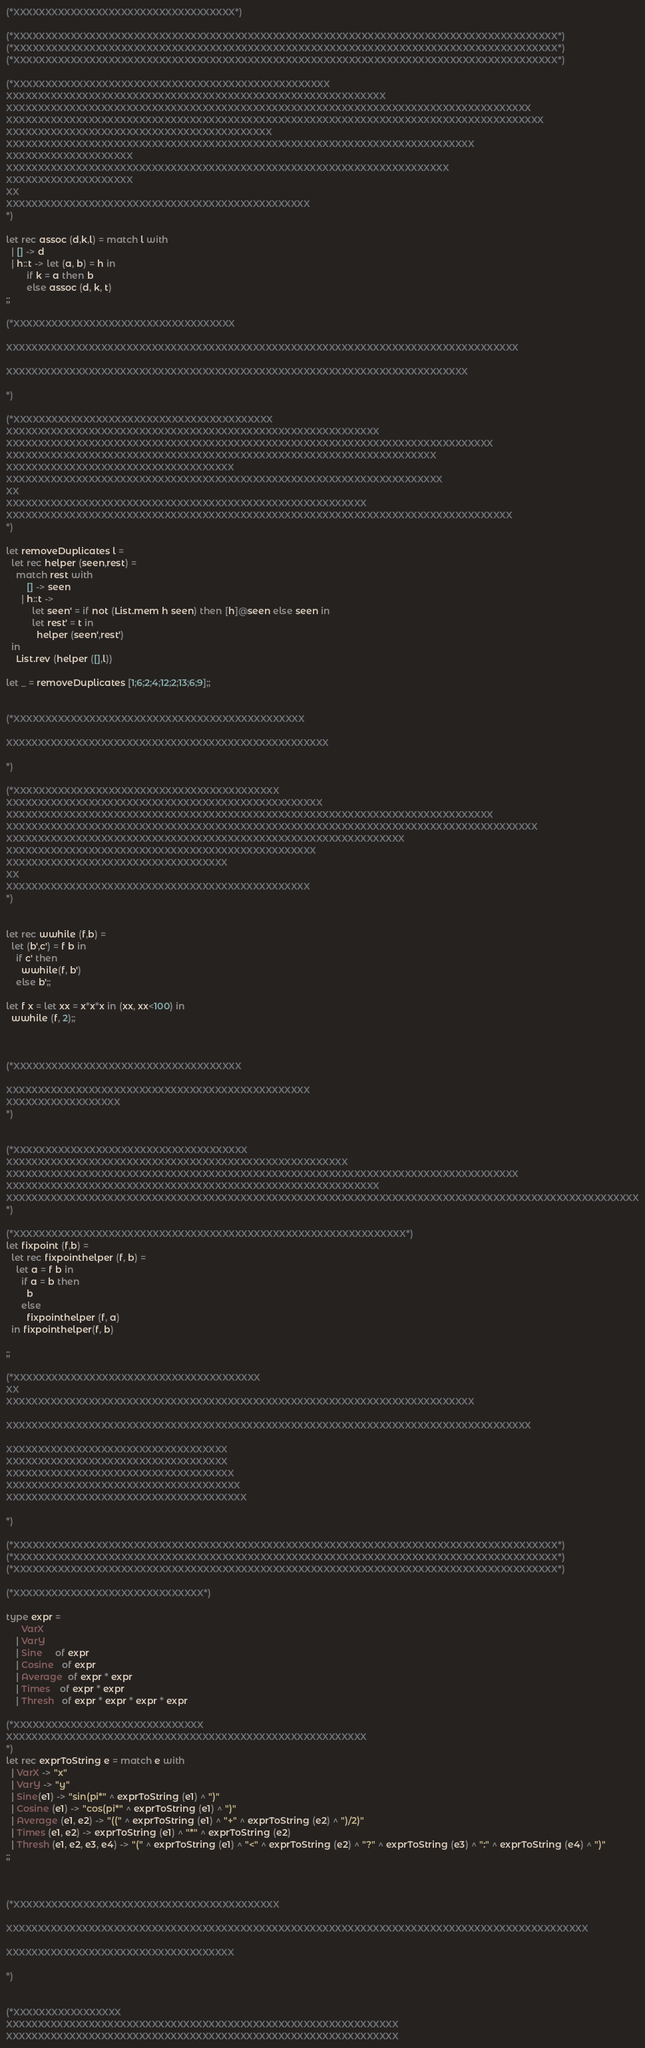Convert code to text. <code><loc_0><loc_0><loc_500><loc_500><_OCaml_>(*XXXXXXXXXXXXXXXXXXXXXXXXXXXXXXXXXXX*)

(*XXXXXXXXXXXXXXXXXXXXXXXXXXXXXXXXXXXXXXXXXXXXXXXXXXXXXXXXXXXXXXXXXXXXXXXXXXXXXXXXXXXXXX*)
(*XXXXXXXXXXXXXXXXXXXXXXXXXXXXXXXXXXXXXXXXXXXXXXXXXXXXXXXXXXXXXXXXXXXXXXXXXXXXXXXXXXXXXX*)
(*XXXXXXXXXXXXXXXXXXXXXXXXXXXXXXXXXXXXXXXXXXXXXXXXXXXXXXXXXXXXXXXXXXXXXXXXXXXXXXXXXXXXXX*)

(*XXXXXXXXXXXXXXXXXXXXXXXXXXXXXXXXXXXXXXXXXXXXXXXXXX
XXXXXXXXXXXXXXXXXXXXXXXXXXXXXXXXXXXXXXXXXXXXXXXXXXXXXXXXXXXX
XXXXXXXXXXXXXXXXXXXXXXXXXXXXXXXXXXXXXXXXXXXXXXXXXXXXXXXXXXXXXXXXXXXXXXXXXXXXXXXXXXX
XXXXXXXXXXXXXXXXXXXXXXXXXXXXXXXXXXXXXXXXXXXXXXXXXXXXXXXXXXXXXXXXXXXXXXXXXXXXXXXXXXXXX
XXXXXXXXXXXXXXXXXXXXXXXXXXXXXXXXXXXXXXXXXX
XXXXXXXXXXXXXXXXXXXXXXXXXXXXXXXXXXXXXXXXXXXXXXXXXXXXXXXXXXXXXXXXXXXXXXXXXX
XXXXXXXXXXXXXXXXXXXX
XXXXXXXXXXXXXXXXXXXXXXXXXXXXXXXXXXXXXXXXXXXXXXXXXXXXXXXXXXXXXXXXXXXXXX
XXXXXXXXXXXXXXXXXXXX
XX
XXXXXXXXXXXXXXXXXXXXXXXXXXXXXXXXXXXXXXXXXXXXXXXX
*)

let rec assoc (d,k,l) = match l with
  | [] -> d
  | h::t -> let (a, b) = h in 
        if k = a then b
        else assoc (d, k, t)
;;

(*XXXXXXXXXXXXXXXXXXXXXXXXXXXXXXXXXXX

XXXXXXXXXXXXXXXXXXXXXXXXXXXXXXXXXXXXXXXXXXXXXXXXXXXXXXXXXXXXXXXXXXXXXXXXXXXXXXXXX

XXXXXXXXXXXXXXXXXXXXXXXXXXXXXXXXXXXXXXXXXXXXXXXXXXXXXXXXXXXXXXXXXXXXXXXXX

*)

(*XXXXXXXXXXXXXXXXXXXXXXXXXXXXXXXXXXXXXXXXX
XXXXXXXXXXXXXXXXXXXXXXXXXXXXXXXXXXXXXXXXXXXXXXXXXXXXXXXXXXX
XXXXXXXXXXXXXXXXXXXXXXXXXXXXXXXXXXXXXXXXXXXXXXXXXXXXXXXXXXXXXXXXXXXXXXXXXXXXX
XXXXXXXXXXXXXXXXXXXXXXXXXXXXXXXXXXXXXXXXXXXXXXXXXXXXXXXXXXXXXXXXXXXX
XXXXXXXXXXXXXXXXXXXXXXXXXXXXXXXXXXXX
XXXXXXXXXXXXXXXXXXXXXXXXXXXXXXXXXXXXXXXXXXXXXXXXXXXXXXXXXXXXXXXXXXXXX
XX
XXXXXXXXXXXXXXXXXXXXXXXXXXXXXXXXXXXXXXXXXXXXXXXXXXXXXXXXX
XXXXXXXXXXXXXXXXXXXXXXXXXXXXXXXXXXXXXXXXXXXXXXXXXXXXXXXXXXXXXXXXXXXXXXXXXXXXXXXX
*)

let removeDuplicates l = 
  let rec helper (seen,rest) = 
    match rest with 
        [] -> seen
      | h::t -> 
          let seen' = if not (List.mem h seen) then [h]@seen else seen in
          let rest' = t in 
            helper (seen',rest') 
  in
    List.rev (helper ([],l))

let _ = removeDuplicates [1;6;2;4;12;2;13;6;9];;


(*XXXXXXXXXXXXXXXXXXXXXXXXXXXXXXXXXXXXXXXXXXXXXX

XXXXXXXXXXXXXXXXXXXXXXXXXXXXXXXXXXXXXXXXXXXXXXXXXXX

*)

(*XXXXXXXXXXXXXXXXXXXXXXXXXXXXXXXXXXXXXXXXXX
XXXXXXXXXXXXXXXXXXXXXXXXXXXXXXXXXXXXXXXXXXXXXXXXXX
XXXXXXXXXXXXXXXXXXXXXXXXXXXXXXXXXXXXXXXXXXXXXXXXXXXXXXXXXXXXXXXXXXXXXXXXXXXXX
XXXXXXXXXXXXXXXXXXXXXXXXXXXXXXXXXXXXXXXXXXXXXXXXXXXXXXXXXXXXXXXXXXXXXXXXXXXXXXXXXXXX
XXXXXXXXXXXXXXXXXXXXXXXXXXXXXXXXXXXXXXXXXXXXXXXXXXXXXXXXXXXXXXX
XXXXXXXXXXXXXXXXXXXXXXXXXXXXXXXXXXXXXXXXXXXXXXXXX
XXXXXXXXXXXXXXXXXXXXXXXXXXXXXXXXXXX
XX
XXXXXXXXXXXXXXXXXXXXXXXXXXXXXXXXXXXXXXXXXXXXXXXX
*)


let rec wwhile (f,b) = 
  let (b',c') = f b in
    if c' then
      wwhile(f, b')
    else b';;

let f x = let xx = x*x*x in (xx, xx<100) in 
  wwhile (f, 2);;



(*XXXXXXXXXXXXXXXXXXXXXXXXXXXXXXXXXXXX

XXXXXXXXXXXXXXXXXXXXXXXXXXXXXXXXXXXXXXXXXXXXXXXX
XXXXXXXXXXXXXXXXXX
*)


(*XXXXXXXXXXXXXXXXXXXXXXXXXXXXXXXXXXXXX
XXXXXXXXXXXXXXXXXXXXXXXXXXXXXXXXXXXXXXXXXXXXXXXXXXXXXX
XXXXXXXXXXXXXXXXXXXXXXXXXXXXXXXXXXXXXXXXXXXXXXXXXXXXXXXXXXXXXXXXXXXXXXXXXXXXXXXXX
XXXXXXXXXXXXXXXXXXXXXXXXXXXXXXXXXXXXXXXXXXXXXXXXXXXXXXXXXXX
XXXXXXXXXXXXXXXXXXXXXXXXXXXXXXXXXXXXXXXXXXXXXXXXXXXXXXXXXXXXXXXXXXXXXXXXXXXXXXXXXXXXXXXXXXXXXXXXXXXX
*)

(*XXXXXXXXXXXXXXXXXXXXXXXXXXXXXXXXXXXXXXXXXXXXXXXXXXXXXXXXXXXXXX*)
let fixpoint (f,b) = 
  let rec fixpointhelper (f, b) =
    let a = f b in
      if a = b then
        b
      else
        fixpointhelper (f, a)
  in fixpointhelper(f, b)

;;

(*XXXXXXXXXXXXXXXXXXXXXXXXXXXXXXXXXXXXXXX
XX
XXXXXXXXXXXXXXXXXXXXXXXXXXXXXXXXXXXXXXXXXXXXXXXXXXXXXXXXXXXXXXXXXXXXXXXXXX

XXXXXXXXXXXXXXXXXXXXXXXXXXXXXXXXXXXXXXXXXXXXXXXXXXXXXXXXXXXXXXXXXXXXXXXXXXXXXXXXXXX

XXXXXXXXXXXXXXXXXXXXXXXXXXXXXXXXXXX
XXXXXXXXXXXXXXXXXXXXXXXXXXXXXXXXXXX
XXXXXXXXXXXXXXXXXXXXXXXXXXXXXXXXXXXX
XXXXXXXXXXXXXXXXXXXXXXXXXXXXXXXXXXXXX
XXXXXXXXXXXXXXXXXXXXXXXXXXXXXXXXXXXXXX

*)

(*XXXXXXXXXXXXXXXXXXXXXXXXXXXXXXXXXXXXXXXXXXXXXXXXXXXXXXXXXXXXXXXXXXXXXXXXXXXXXXXXXXXXXX*)
(*XXXXXXXXXXXXXXXXXXXXXXXXXXXXXXXXXXXXXXXXXXXXXXXXXXXXXXXXXXXXXXXXXXXXXXXXXXXXXXXXXXXXXX*)
(*XXXXXXXXXXXXXXXXXXXXXXXXXXXXXXXXXXXXXXXXXXXXXXXXXXXXXXXXXXXXXXXXXXXXXXXXXXXXXXXXXXXXXX*)

(*XXXXXXXXXXXXXXXXXXXXXXXXXXXXXX*) 

type expr = 
      VarX
    | VarY
    | Sine     of expr
    | Cosine   of expr
    | Average  of expr * expr
    | Times    of expr * expr
    | Thresh   of expr * expr * expr * expr	

(*XXXXXXXXXXXXXXXXXXXXXXXXXXXXXX
XXXXXXXXXXXXXXXXXXXXXXXXXXXXXXXXXXXXXXXXXXXXXXXXXXXXXXXXX
*)
let rec exprToString e = match e with
  | VarX -> "x"
  | VarY -> "y"
  | Sine(e1) -> "sin(pi*" ^ exprToString (e1) ^ ")"
  | Cosine (e1) -> "cos(pi*" ^ exprToString (e1) ^ ")"
  | Average (e1, e2) -> "((" ^ exprToString (e1) ^ "+" ^ exprToString (e2) ^ ")/2)"
  | Times (e1, e2) -> exprToString (e1) ^ "*" ^ exprToString (e2)
  | Thresh (e1, e2, e3, e4) -> "(" ^ exprToString (e1) ^ "<" ^ exprToString (e2) ^ "?" ^ exprToString (e3) ^ ":" ^ exprToString (e4) ^ ")"
;;



(*XXXXXXXXXXXXXXXXXXXXXXXXXXXXXXXXXXXXXXXXXX

XXXXXXXXXXXXXXXXXXXXXXXXXXXXXXXXXXXXXXXXXXXXXXXXXXXXXXXXXXXXXXXXXXXXXXXXXXXXXXXXXXXXXXXXXXXX

XXXXXXXXXXXXXXXXXXXXXXXXXXXXXXXXXXXX

*)


(*XXXXXXXXXXXXXXXXX
XXXXXXXXXXXXXXXXXXXXXXXXXXXXXXXXXXXXXXXXXXXXXXXXXXXXXXXXXXXXXX
XXXXXXXXXXXXXXXXXXXXXXXXXXXXXXXXXXXXXXXXXXXXXXXXXXXXXXXXXXXXXX</code> 